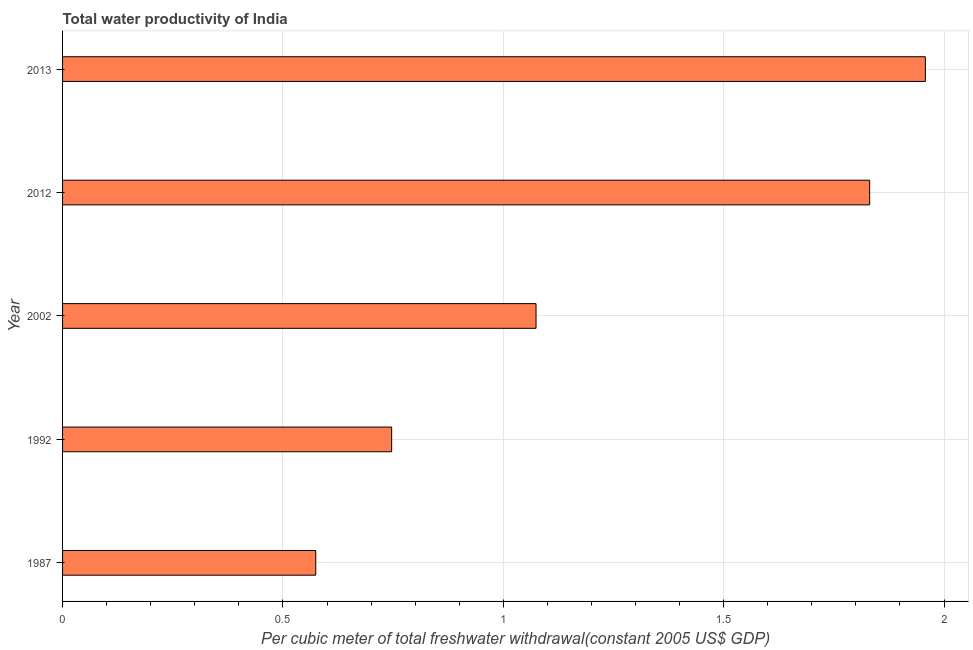Does the graph contain grids?
Make the answer very short. Yes. What is the title of the graph?
Offer a terse response. Total water productivity of India. What is the label or title of the X-axis?
Offer a very short reply. Per cubic meter of total freshwater withdrawal(constant 2005 US$ GDP). What is the total water productivity in 2012?
Offer a terse response. 1.83. Across all years, what is the maximum total water productivity?
Your answer should be very brief. 1.96. Across all years, what is the minimum total water productivity?
Ensure brevity in your answer.  0.57. In which year was the total water productivity minimum?
Provide a short and direct response. 1987. What is the sum of the total water productivity?
Keep it short and to the point. 6.18. What is the difference between the total water productivity in 1987 and 2013?
Offer a terse response. -1.38. What is the average total water productivity per year?
Provide a succinct answer. 1.24. What is the median total water productivity?
Offer a terse response. 1.07. In how many years, is the total water productivity greater than 0.7 US$?
Offer a terse response. 4. What is the ratio of the total water productivity in 1992 to that in 2002?
Offer a very short reply. 0.69. Is the difference between the total water productivity in 1992 and 2002 greater than the difference between any two years?
Offer a very short reply. No. What is the difference between the highest and the second highest total water productivity?
Ensure brevity in your answer.  0.13. What is the difference between the highest and the lowest total water productivity?
Offer a very short reply. 1.38. How many bars are there?
Keep it short and to the point. 5. How many years are there in the graph?
Give a very brief answer. 5. Are the values on the major ticks of X-axis written in scientific E-notation?
Your response must be concise. No. What is the Per cubic meter of total freshwater withdrawal(constant 2005 US$ GDP) of 1987?
Your answer should be very brief. 0.57. What is the Per cubic meter of total freshwater withdrawal(constant 2005 US$ GDP) of 1992?
Offer a terse response. 0.75. What is the Per cubic meter of total freshwater withdrawal(constant 2005 US$ GDP) of 2002?
Your answer should be compact. 1.07. What is the Per cubic meter of total freshwater withdrawal(constant 2005 US$ GDP) of 2012?
Your response must be concise. 1.83. What is the Per cubic meter of total freshwater withdrawal(constant 2005 US$ GDP) of 2013?
Provide a short and direct response. 1.96. What is the difference between the Per cubic meter of total freshwater withdrawal(constant 2005 US$ GDP) in 1987 and 1992?
Provide a succinct answer. -0.17. What is the difference between the Per cubic meter of total freshwater withdrawal(constant 2005 US$ GDP) in 1987 and 2002?
Keep it short and to the point. -0.5. What is the difference between the Per cubic meter of total freshwater withdrawal(constant 2005 US$ GDP) in 1987 and 2012?
Make the answer very short. -1.26. What is the difference between the Per cubic meter of total freshwater withdrawal(constant 2005 US$ GDP) in 1987 and 2013?
Make the answer very short. -1.38. What is the difference between the Per cubic meter of total freshwater withdrawal(constant 2005 US$ GDP) in 1992 and 2002?
Your response must be concise. -0.33. What is the difference between the Per cubic meter of total freshwater withdrawal(constant 2005 US$ GDP) in 1992 and 2012?
Make the answer very short. -1.08. What is the difference between the Per cubic meter of total freshwater withdrawal(constant 2005 US$ GDP) in 1992 and 2013?
Ensure brevity in your answer.  -1.21. What is the difference between the Per cubic meter of total freshwater withdrawal(constant 2005 US$ GDP) in 2002 and 2012?
Your answer should be very brief. -0.76. What is the difference between the Per cubic meter of total freshwater withdrawal(constant 2005 US$ GDP) in 2002 and 2013?
Ensure brevity in your answer.  -0.88. What is the difference between the Per cubic meter of total freshwater withdrawal(constant 2005 US$ GDP) in 2012 and 2013?
Offer a very short reply. -0.13. What is the ratio of the Per cubic meter of total freshwater withdrawal(constant 2005 US$ GDP) in 1987 to that in 1992?
Give a very brief answer. 0.77. What is the ratio of the Per cubic meter of total freshwater withdrawal(constant 2005 US$ GDP) in 1987 to that in 2002?
Keep it short and to the point. 0.54. What is the ratio of the Per cubic meter of total freshwater withdrawal(constant 2005 US$ GDP) in 1987 to that in 2012?
Your answer should be compact. 0.31. What is the ratio of the Per cubic meter of total freshwater withdrawal(constant 2005 US$ GDP) in 1987 to that in 2013?
Give a very brief answer. 0.29. What is the ratio of the Per cubic meter of total freshwater withdrawal(constant 2005 US$ GDP) in 1992 to that in 2002?
Your response must be concise. 0.69. What is the ratio of the Per cubic meter of total freshwater withdrawal(constant 2005 US$ GDP) in 1992 to that in 2012?
Provide a succinct answer. 0.41. What is the ratio of the Per cubic meter of total freshwater withdrawal(constant 2005 US$ GDP) in 1992 to that in 2013?
Your answer should be compact. 0.38. What is the ratio of the Per cubic meter of total freshwater withdrawal(constant 2005 US$ GDP) in 2002 to that in 2012?
Offer a terse response. 0.59. What is the ratio of the Per cubic meter of total freshwater withdrawal(constant 2005 US$ GDP) in 2002 to that in 2013?
Offer a very short reply. 0.55. What is the ratio of the Per cubic meter of total freshwater withdrawal(constant 2005 US$ GDP) in 2012 to that in 2013?
Offer a very short reply. 0.94. 